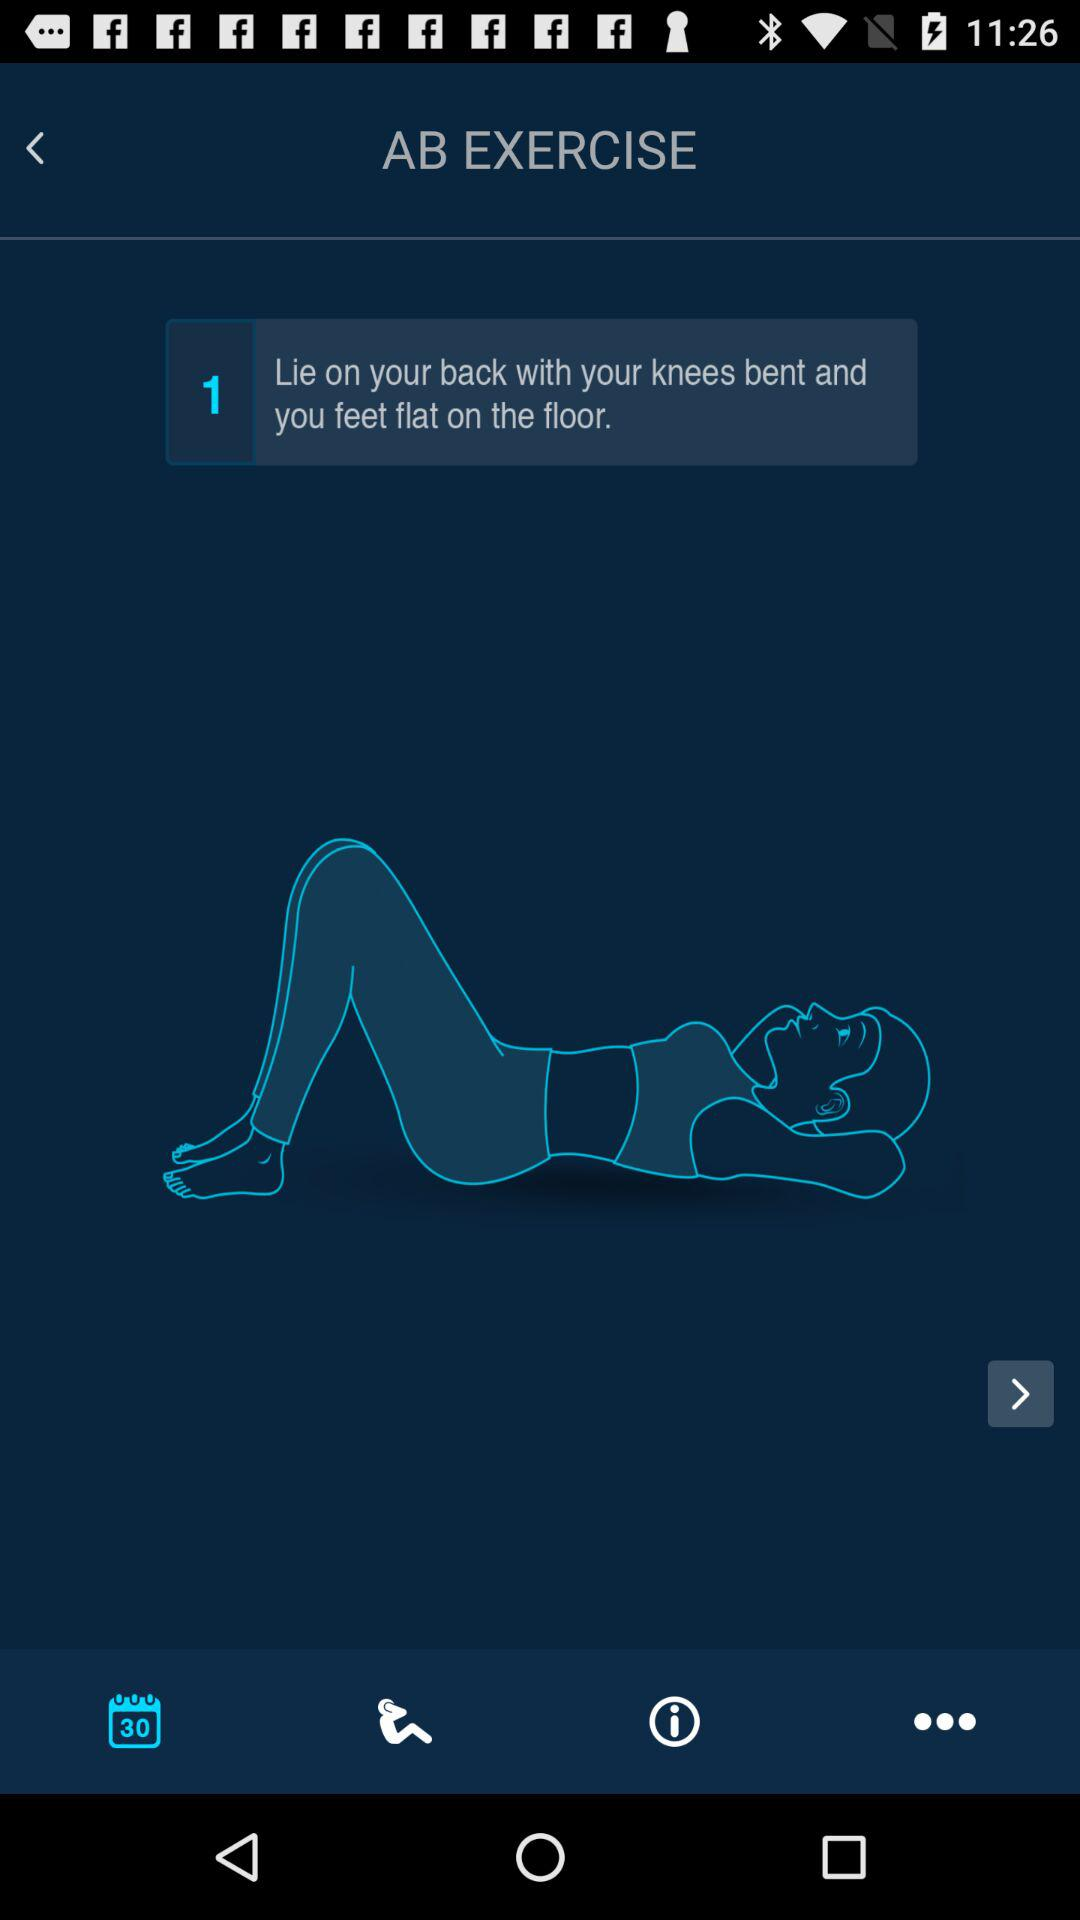What is the name of the exercise? The name of the exercise is "AB EXERCISE". 